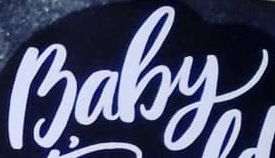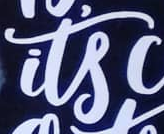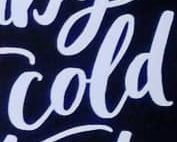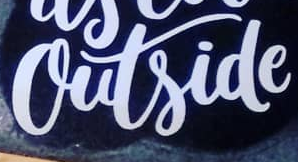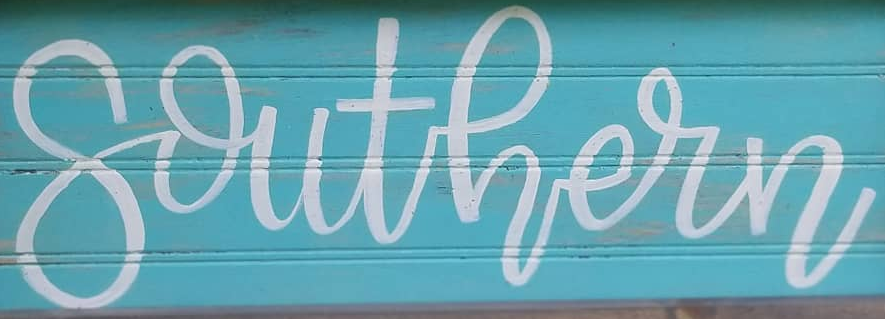What text appears in these images from left to right, separated by a semicolon? Baby; its; cold; outside; southern 